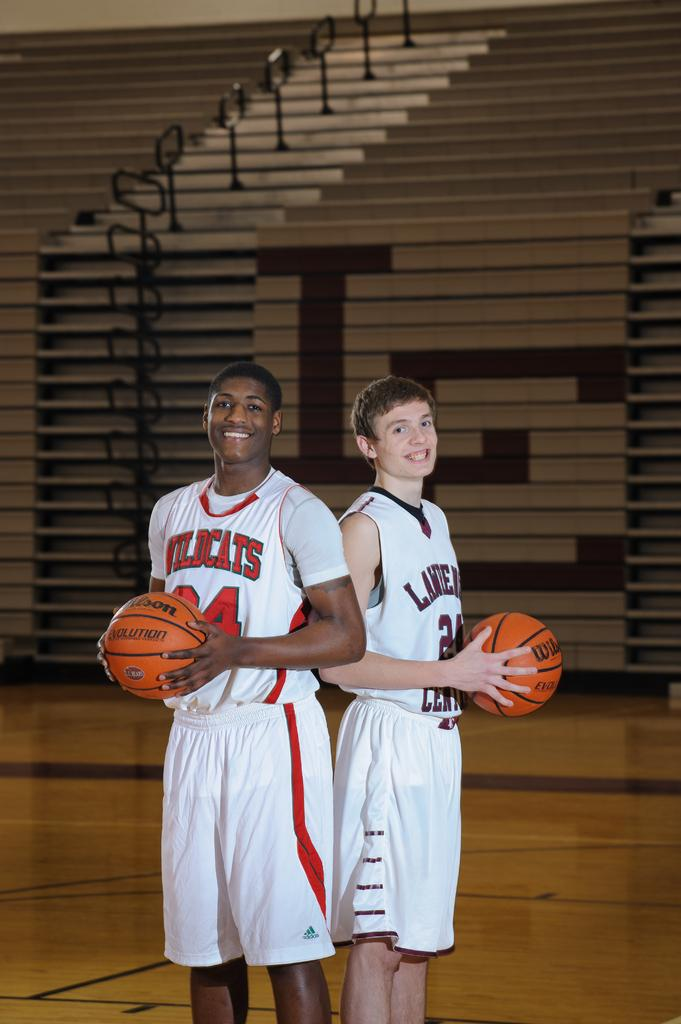<image>
Render a clear and concise summary of the photo. A boy in a Wildcats uniform stands next to another boy for a photo. 